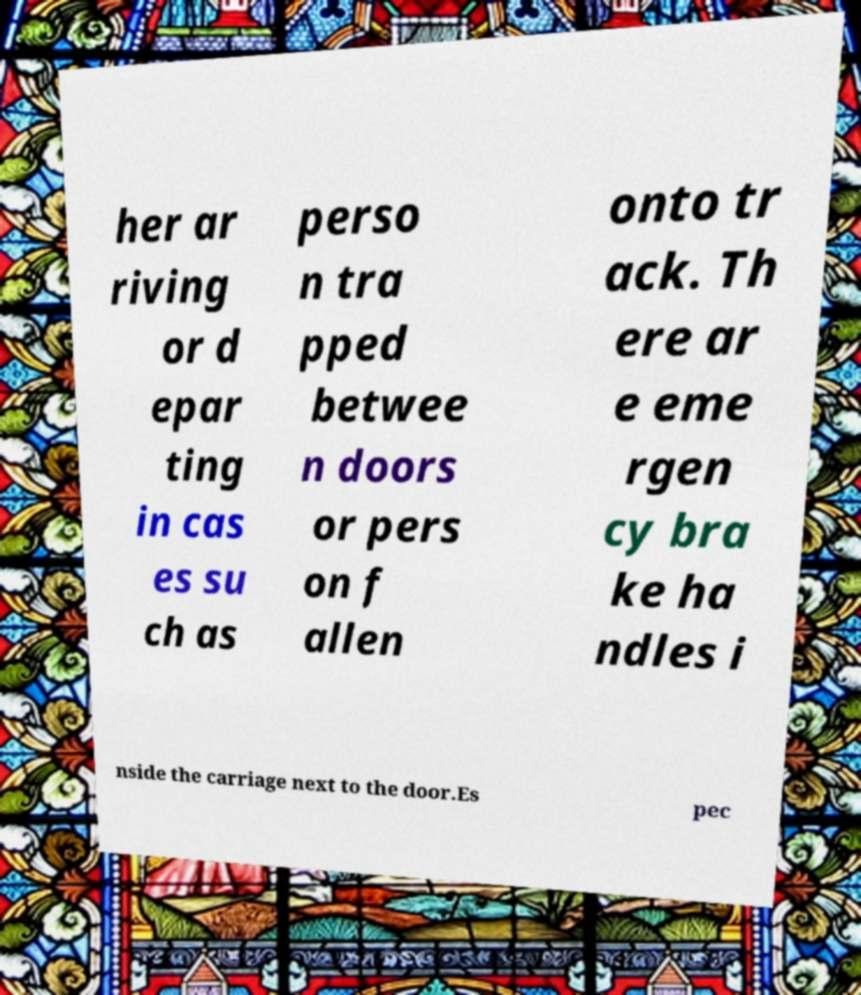Could you extract and type out the text from this image? her ar riving or d epar ting in cas es su ch as perso n tra pped betwee n doors or pers on f allen onto tr ack. Th ere ar e eme rgen cy bra ke ha ndles i nside the carriage next to the door.Es pec 